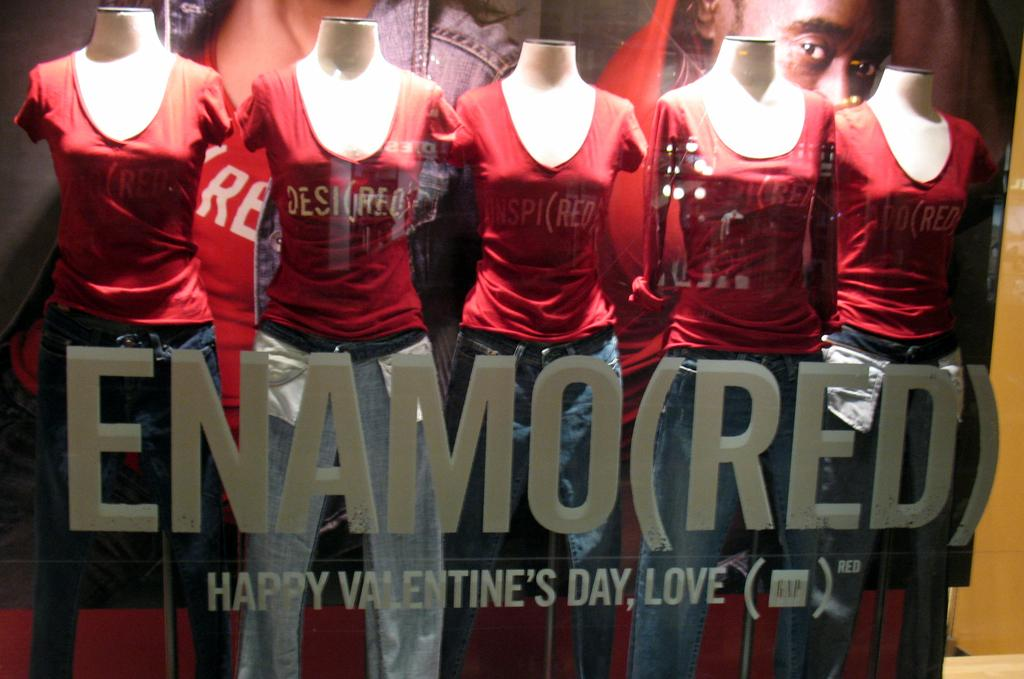<image>
Describe the image concisely. A set of mannequins are behind a sign marked Enamo(red) Happy Valentine's Day Love. 